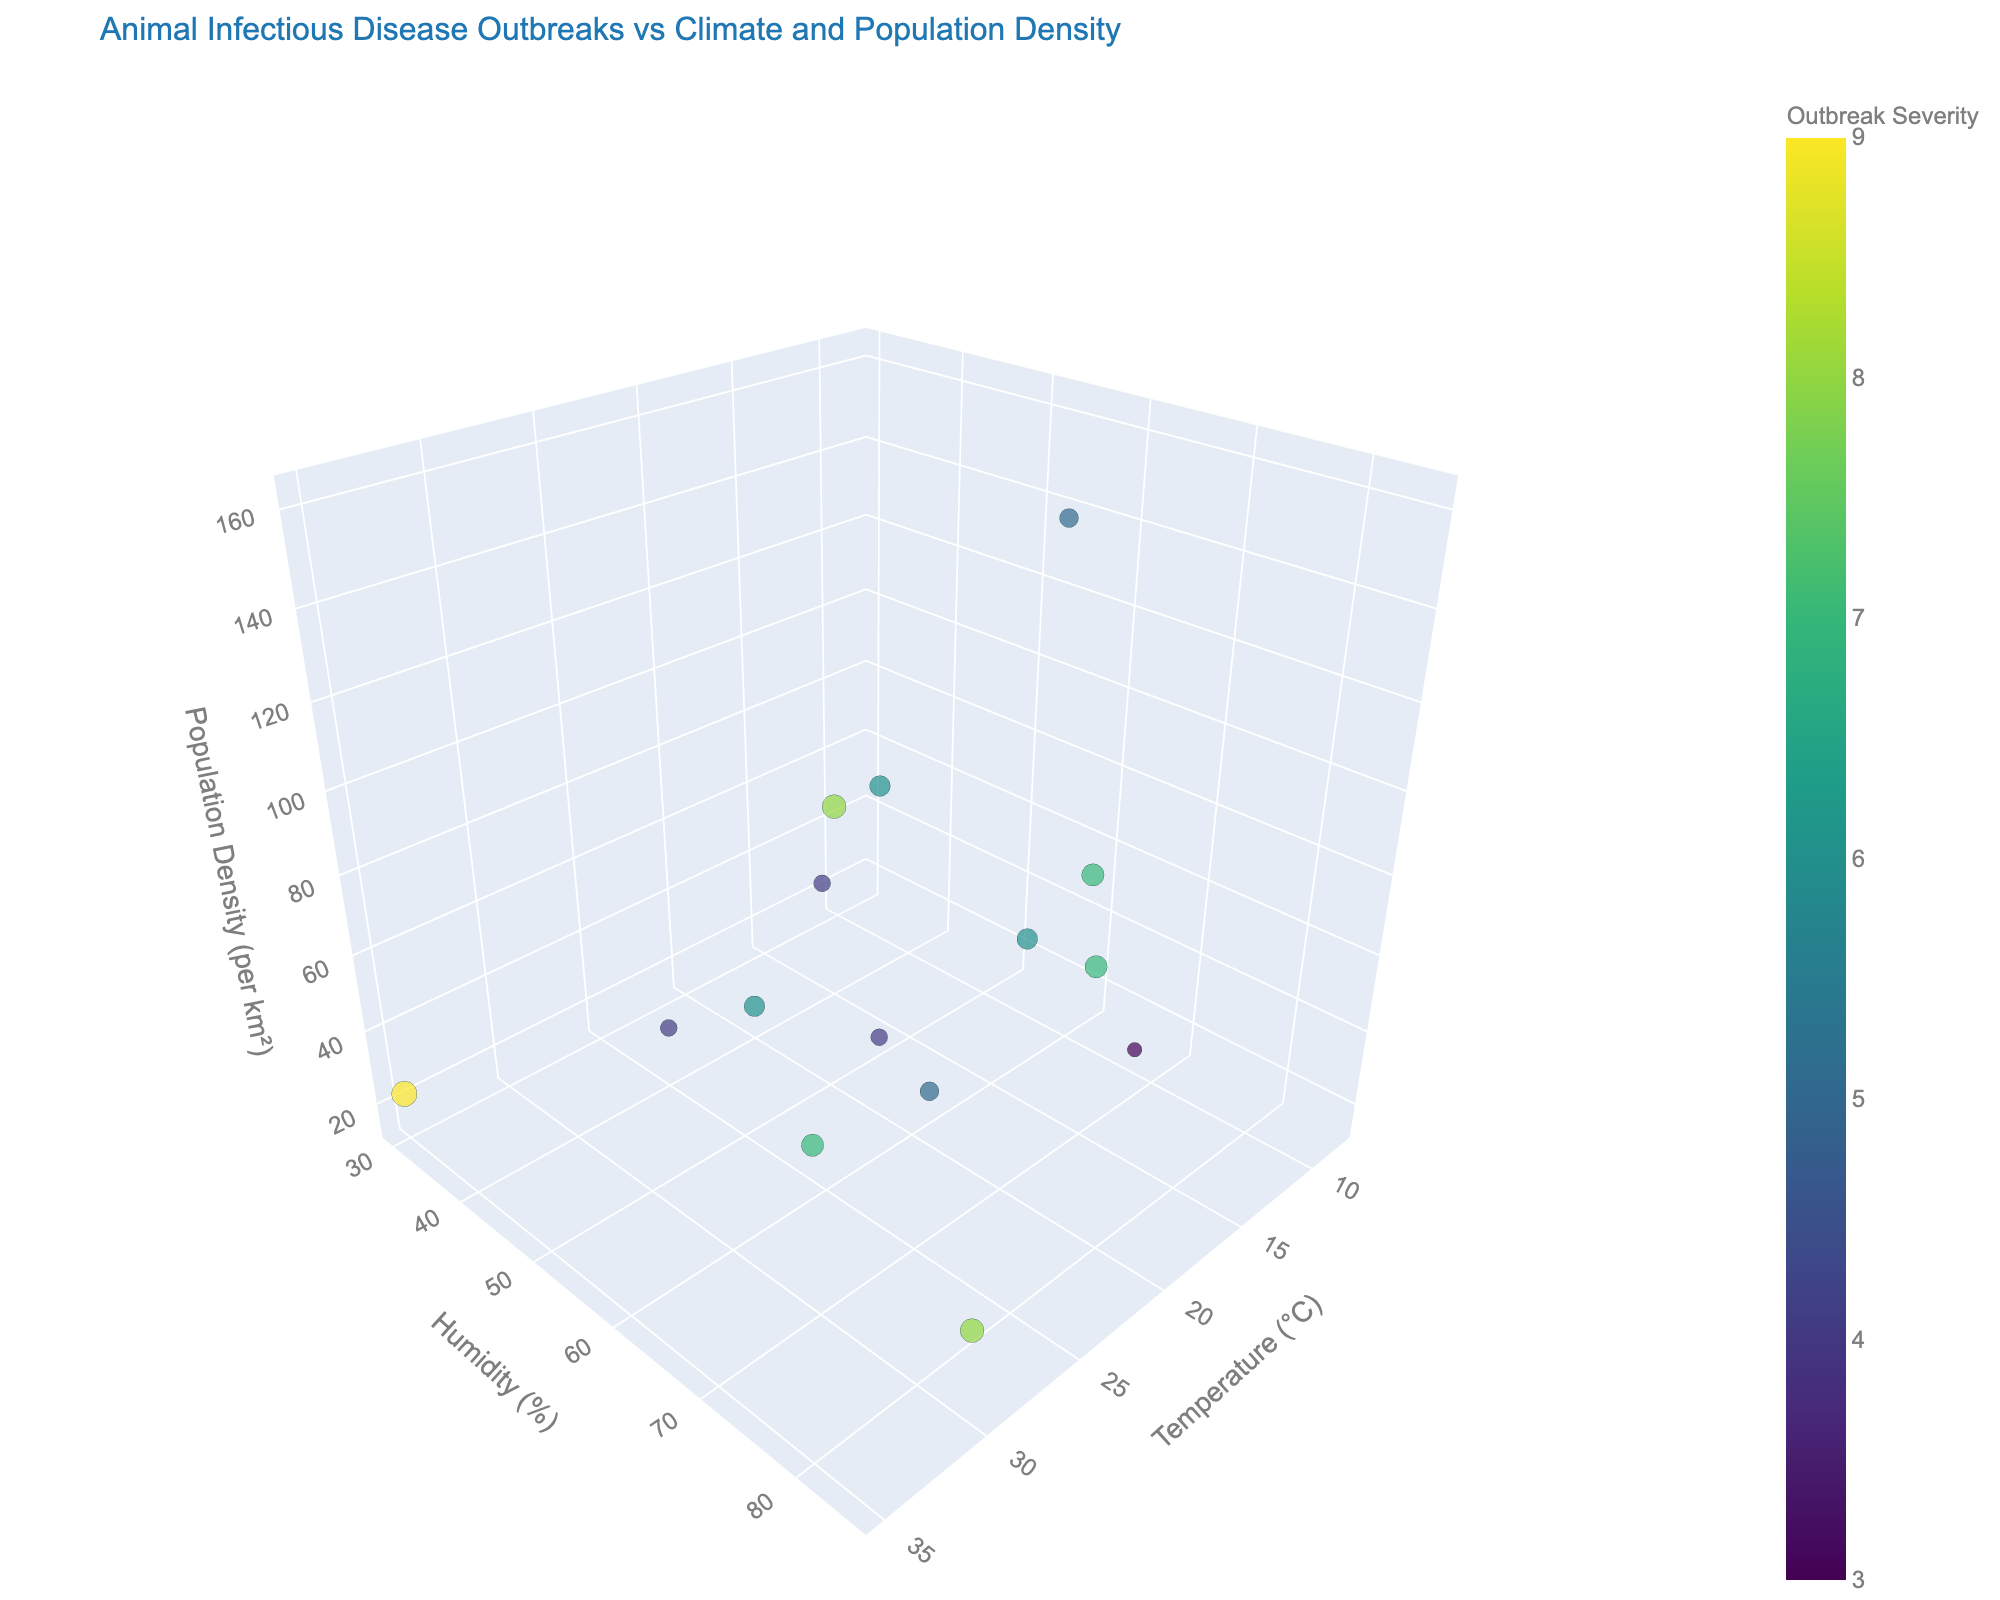What is the title of the plot? The title of the plot is prominently displayed at the top of the figure. It provides an overview of what the plot represents.
Answer: "Animal Infectious Disease Outbreaks vs Climate and Population Density" Which region has the highest outbreak severity? The region with the highest outbreak severity can be identified by looking for the largest and/or the darkest colored marker in the plot.
Answer: Arizona How do temperature and humidity appear to be related to the regions with the highest population density? Observing the axis and markers, regions with higher population density seem to cluster around moderate temperatures and varied humidity levels.
Answer: They seem to cluster around moderate temperatures and variable humidity Which disease has an outbreak severity of 8 and what region does it occur in? By referring to the hover data associated with each marker, identify the marker that shows an outbreak severity of 8. Then, check the disease and region associated with it.
Answer: Avian Influenza in California What is the approximate relationship between temperature and outbreak severity? From the plot, observe the trend of the outbreak severity markers along the temperature axis. Evaluate if higher or lower temperatures correspond to higher severity.
Answer: Higher temperatures are generally associated with higher outbreak severity Do the regions with the lowest humidity show a significant correlation with outbreak severity? Look at the markers along the low end of the humidity axis and their corresponding outbreak severity colors and sizes to see any patterns.
Answer: Yes, they show higher outbreak severity Compare the outbreak severity of Leptospirosis and Canine Distemper. Which one is higher? Locate the markers for Leptospirosis in New York and Canine Distemper in Texas and compare their colors and sizes.
Answer: Canine Distemper Which region has both high humidity and high population density but a relatively low outbreak severity? Identify markers with high values on both the humidity and population density axes, then check their color and size for outbreak severity.
Answer: New York What can be inferred about the relationship between population density and outbreak severity in regions with low temperatures? Examine the markers at lower temperature values and observe their population density and corresponding outbreak severity sizes and colors.
Answer: Regions with low temperatures and high population densities tend to have lower outbreak severity 